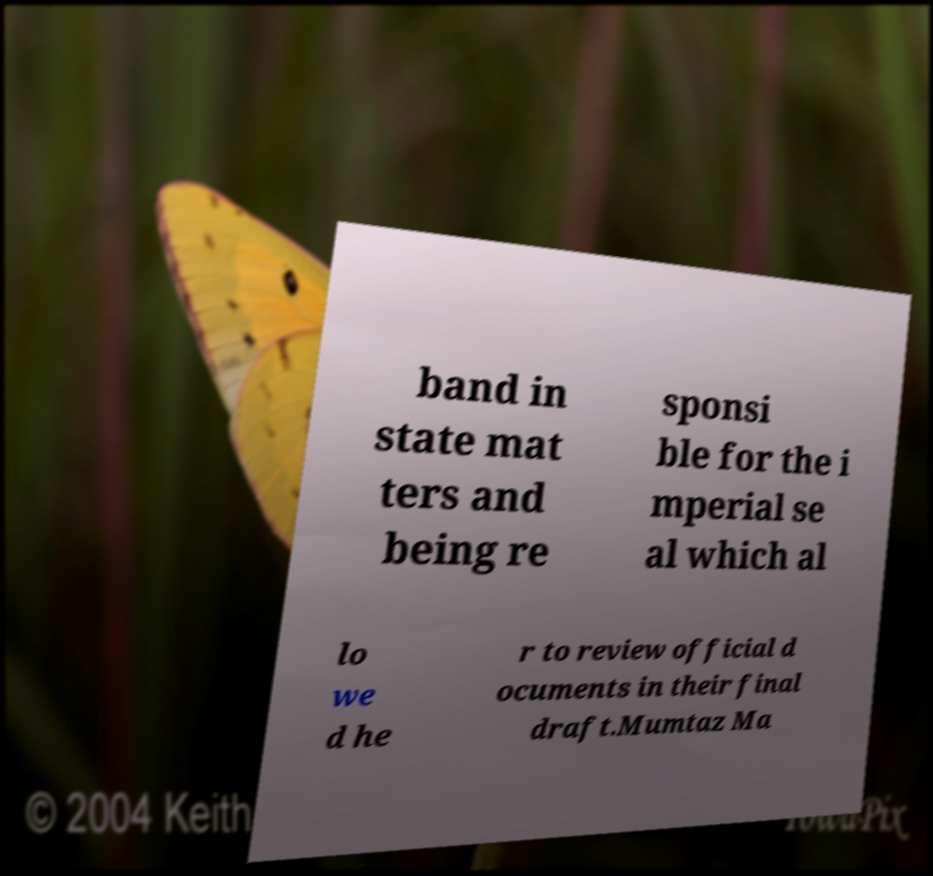Please read and relay the text visible in this image. What does it say? band in state mat ters and being re sponsi ble for the i mperial se al which al lo we d he r to review official d ocuments in their final draft.Mumtaz Ma 